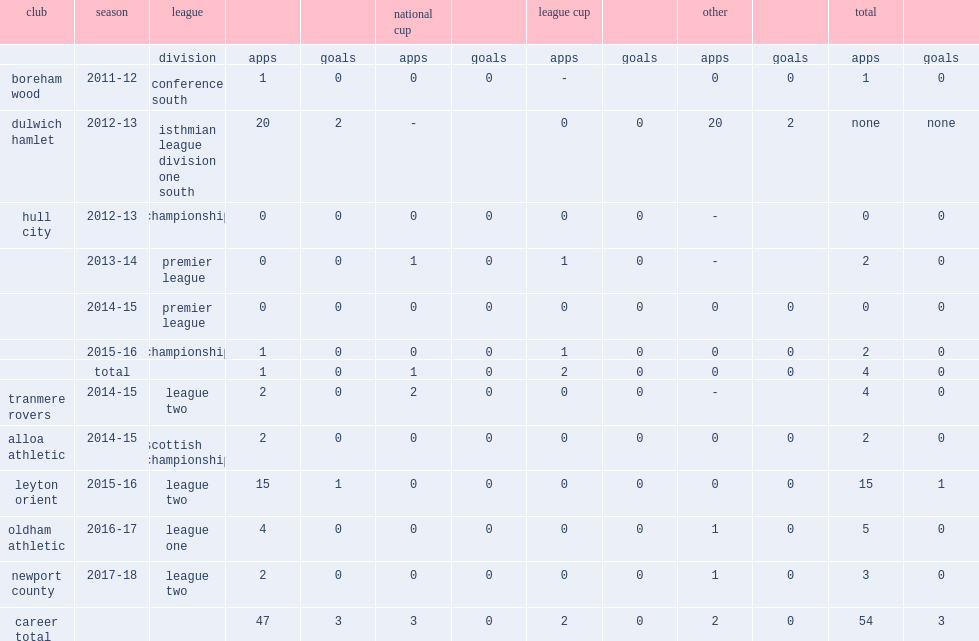How many league goals did jahraldo-martin score for dulwich hamlet in 2012-13? 2.0. 